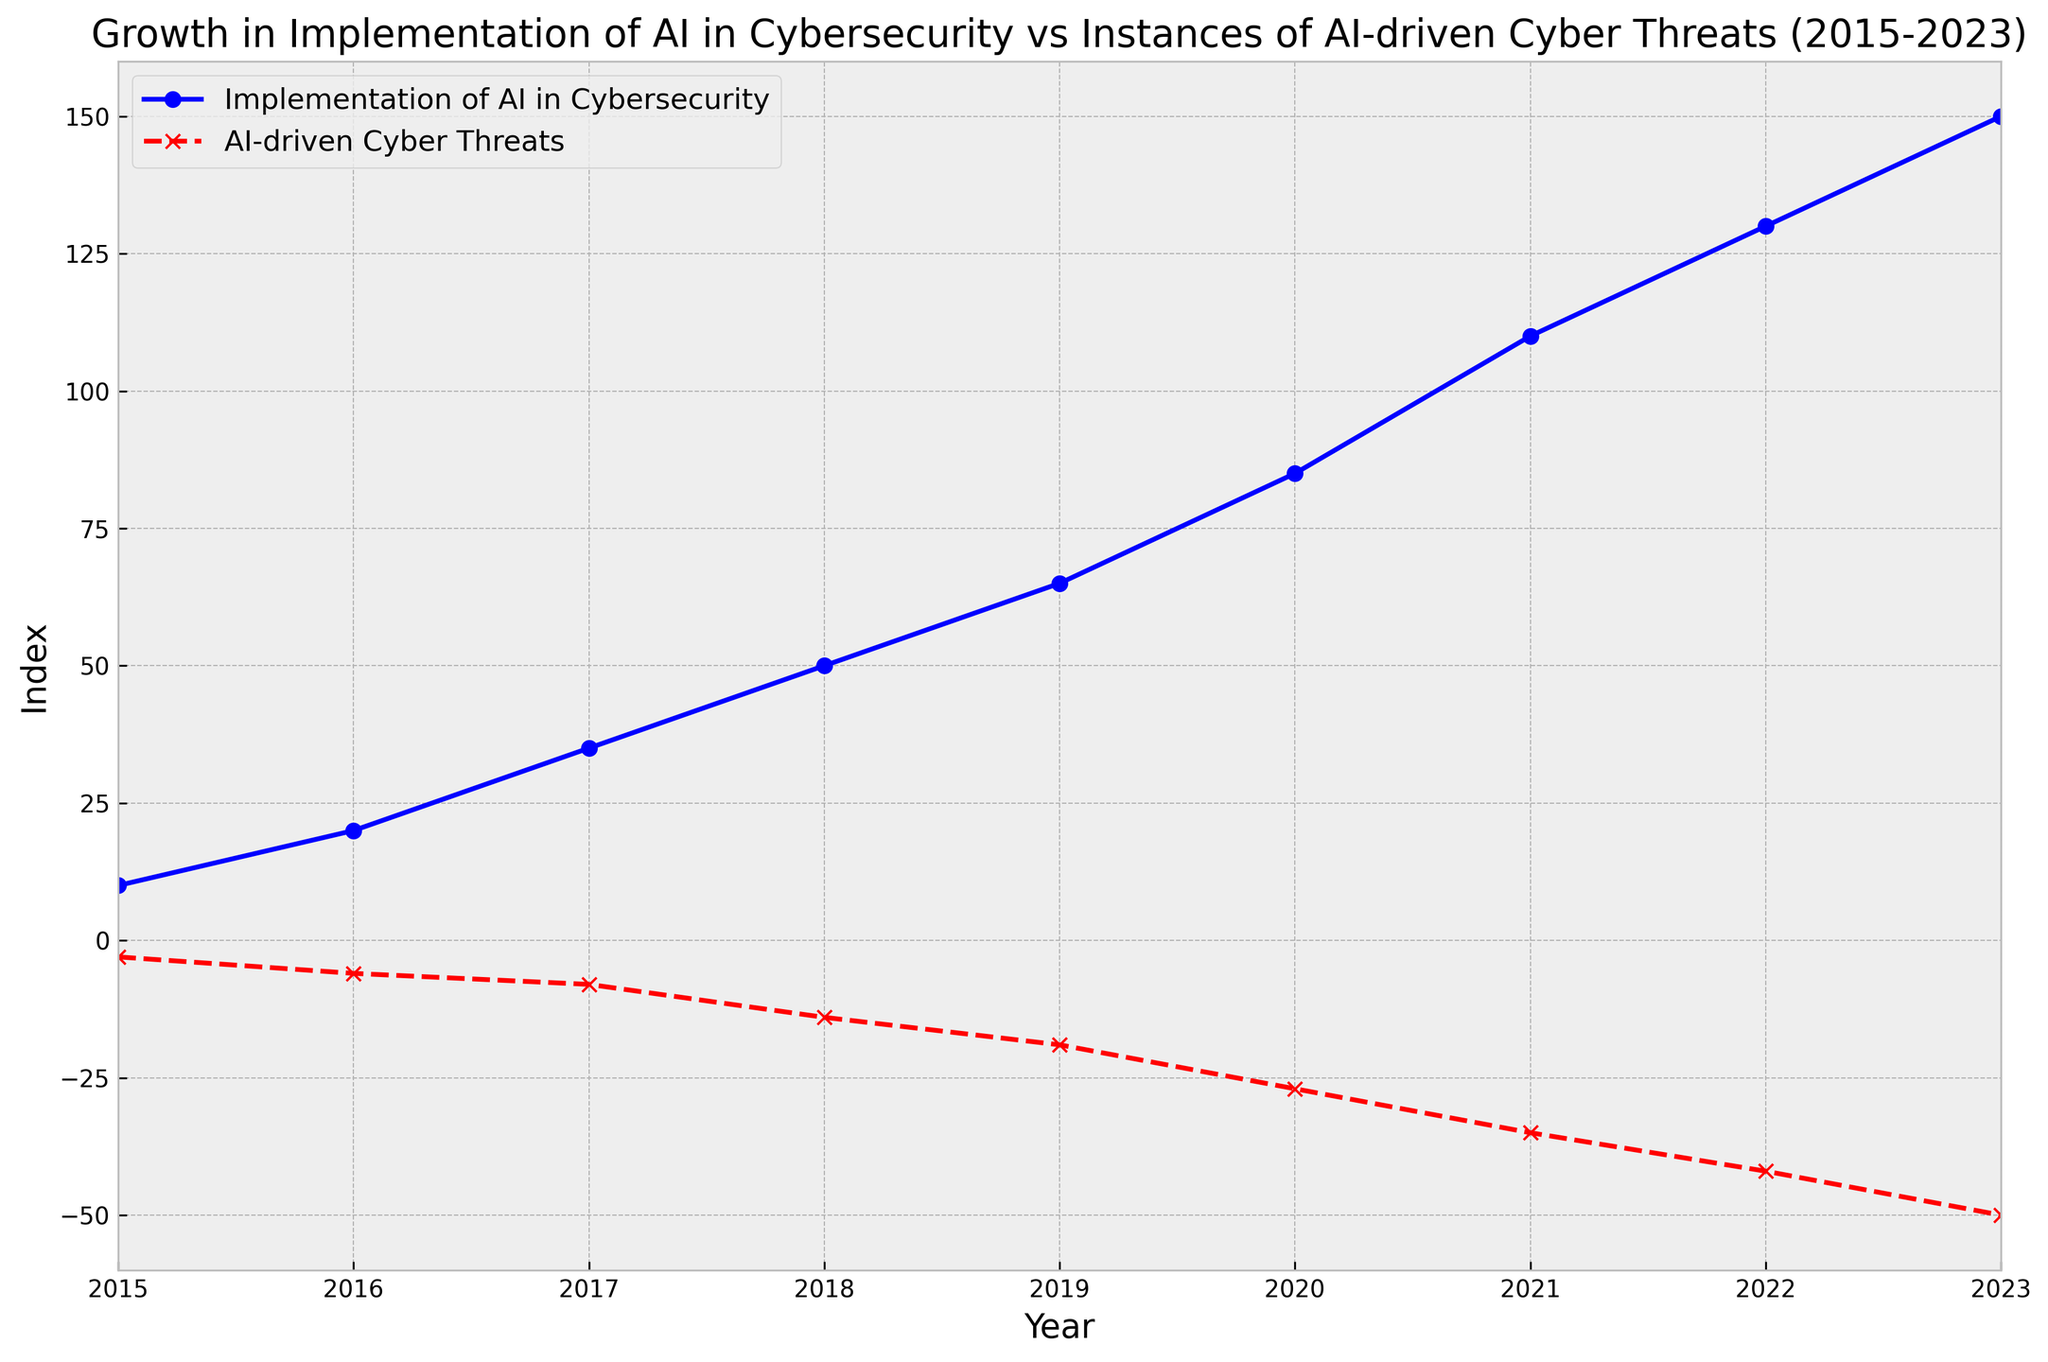How does the implementation of AI in cybersecurity change from 2015 to 2023? The implementation increases steadily from an index of 10 in 2015 to an index of 150 in 2023 as indicated by the blue line with circles.
Answer: It increases What's the trend of AI-driven cyber threats between 2015 and 2023? The level of AI-driven cyber threats consistently worsens, with the index dropping from -3 in 2015 to -50 in 2023 as shown by the red dashed line with crosses.
Answer: It worsens In which year do we see the biggest difference in indices between the implementation of AI in cybersecurity and AI-driven cyber threats? In 2023, the difference is the largest: 150 (implementation) - (-50) (threats) = 200. This is depicted by the longest vertical distance between the blue and red lines.
Answer: 2023 By what amount did the implementation of AI in cybersecurity increase from 2017 to 2019? In 2017, the index is 35, and in 2019, it is 65. The difference is 65 - 35 = 30.
Answer: 30 Compare the indices of AI-driven cyber threats in 2016 and 2020. In 2016, the index is -6, and in 2020, it is -27. Since -6 > -27, it indicates that threats have worsened over these years.
Answer: -6 > -27 Which year had the steepest increase in the implementation of AI in cybersecurity? Observing the plot, the steepest increase is between 2020 (index 85) and 2021 (index 110), with an increase of 25, as indicated by the steepest upward slope of the blue line.
Answer: 2020-2021 How did AI-driven cyber threats change from 2018 to 2023? The index worsened from -14 in 2018 to -50 in 2023, showing a decline (or worsening) by 50 - 14 = 36 units.
Answer: Worsened by 36 units What is the color used to represent AI-driven cyber threats, and what does it signify in the plot? The plot uses a red dashed line with crosses to signify AI-driven cyber threats, indicating a consistent worsening trend over the years.
Answer: Red, worsening trend 